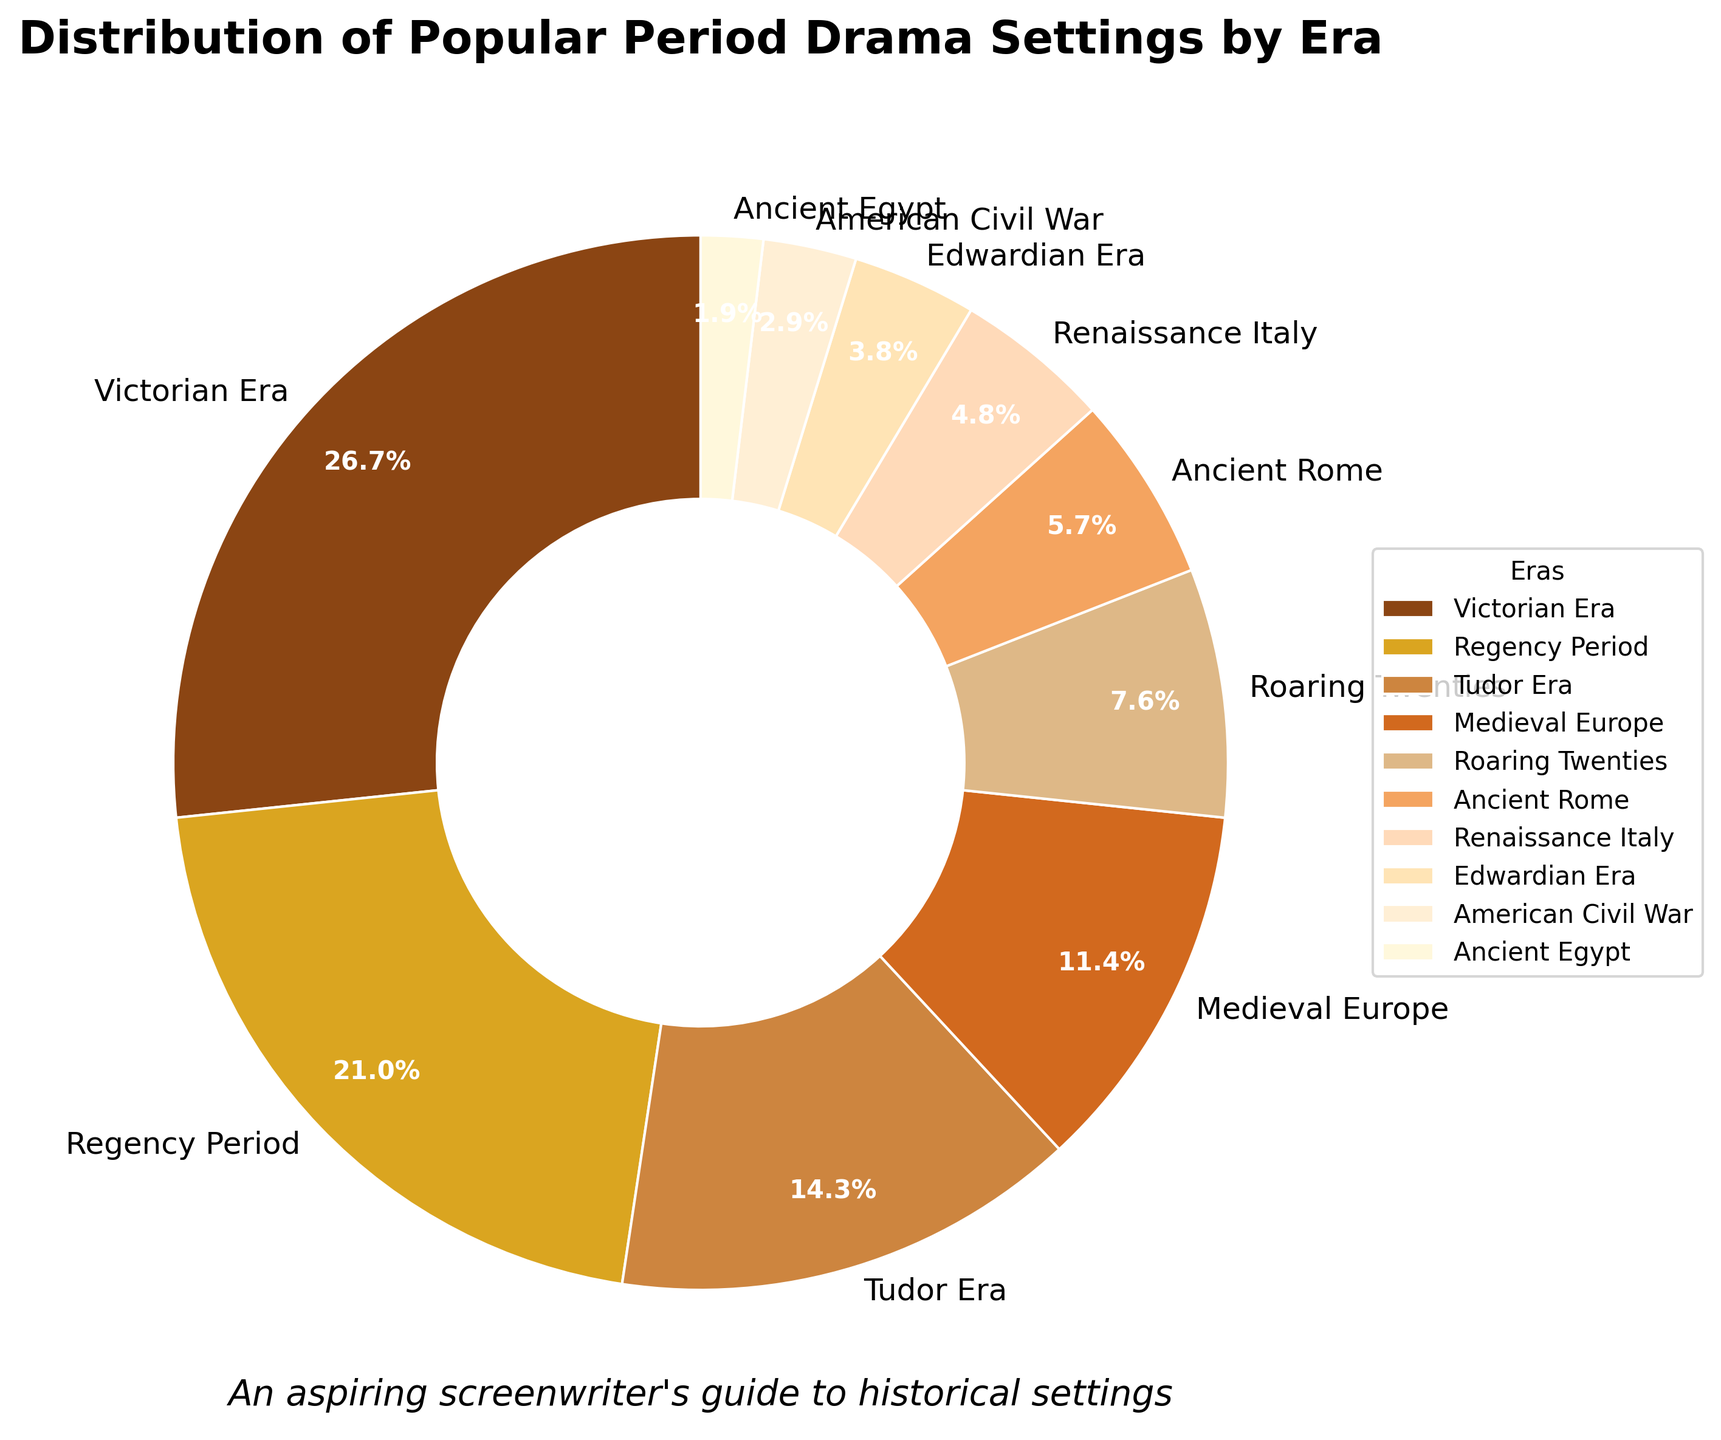What's the most prevalent era depicted in period dramas in the pie chart? The most prevalent era can be identified by finding the largest segment of the pie chart, which is labeled "Victorian Era" with a percentage of 28%.
Answer: Victorian Era Which era has the smallest representation in the pie chart, and what percentage does it have? The smallest segment of the pie chart is the one representing the "Ancient Egypt" era with a percentage of 2%.
Answer: Ancient Egypt, 2% How do the shares of the Victorian Era and the Tudor Era compare? The segment representing the Victorian Era is 28% while the Tudor Era is 15%, meaning the Victorian Era has a larger share than the Tudor Era by 13 percentage points.
Answer: Victorian Era is larger by 13% If we combine the shares of the Roaring Twenties and Renaissance Italy, what is their total percentage? The Roaring Twenties accounts for 8% and Renaissance Italy is 5%. Adding these together gives a total of 13%.
Answer: 13% How many eras have a representation of more than 10% each? Observing the pie chart, the Victorian Era, Regency Period, and Tudor Era each have percentages greater than 10% (28%, 22%, and 15%, respectively), thus there are three such eras.
Answer: Three eras Is the percentage representation of the Edwardian Era greater than that of the American Civil War era? Comparing the two segments, the Edwardian Era is represented by 4%, while the American Civil War era is represented by 3%. Therefore, the Edwardian Era has a greater percentage.
Answer: Yes What is the cumulative percentage of all the eras that have less than 10% representation individually? Adding the percentages for the Roaring Twenties (8%), Ancient Rome (6%), Renaissance Italy (5%), Edwardian Era (4%), American Civil War (3%), and Ancient Egypt (2%) results in a sum of 28%.
Answer: 28% Between Ancient Rome and Ancient Egypt, which era is depicted more frequently, and by how much? Ancient Rome has a representation of 6%, while Ancient Egypt has 2%. The difference is 4 percentage points, making Ancient Rome more frequently depicted.
Answer: Ancient Rome by 4% Which era is represented by a segment directly bordering both the largest and smallest segments of the pie chart? The largest segment is the Victorian Era (28%) and the smallest is Ancient Egypt (2%). The Edwardian Era (4%) borders both of these sections in the pie chart.
Answer: Edwardian Era If we group Medieval Europe and Renaissance Italy together as a single category of "European Pre-Modern Eras", what would be their combined percentage? Medieval Europe has a representation of 12%, and Renaissance Italy has 5%. Their combined total as "European Pre-Modern Eras" would be 17%.
Answer: 17% 